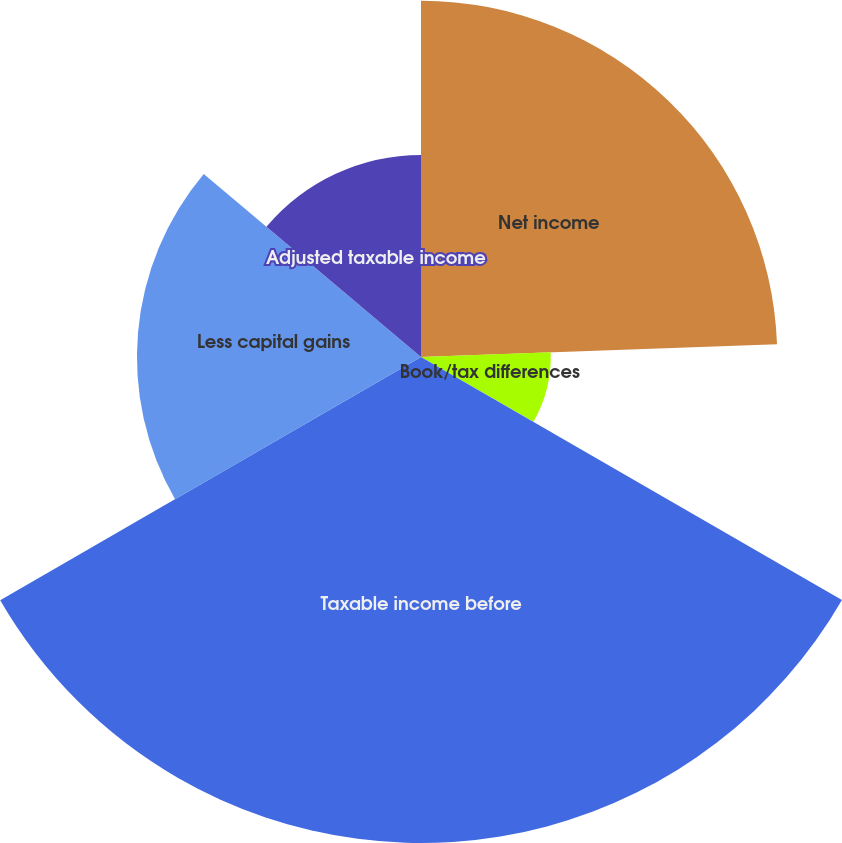Convert chart to OTSL. <chart><loc_0><loc_0><loc_500><loc_500><pie_chart><fcel>Net income<fcel>Book/tax differences<fcel>Taxable income before<fcel>Less capital gains<fcel>Adjusted taxable income<nl><fcel>24.43%<fcel>8.9%<fcel>33.33%<fcel>19.48%<fcel>13.86%<nl></chart> 